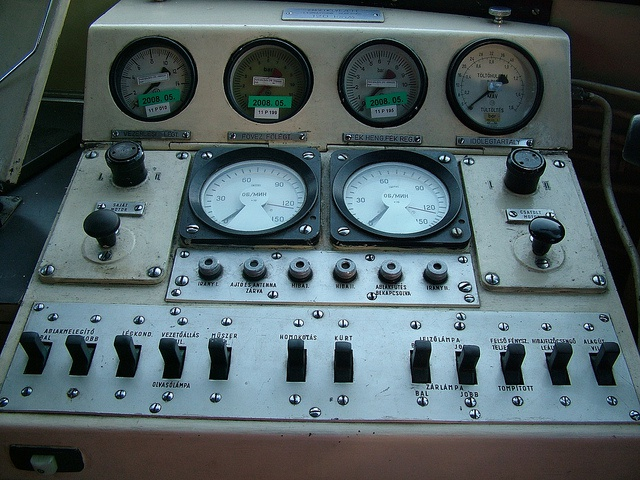Describe the objects in this image and their specific colors. I can see various objects in this image with different colors. 